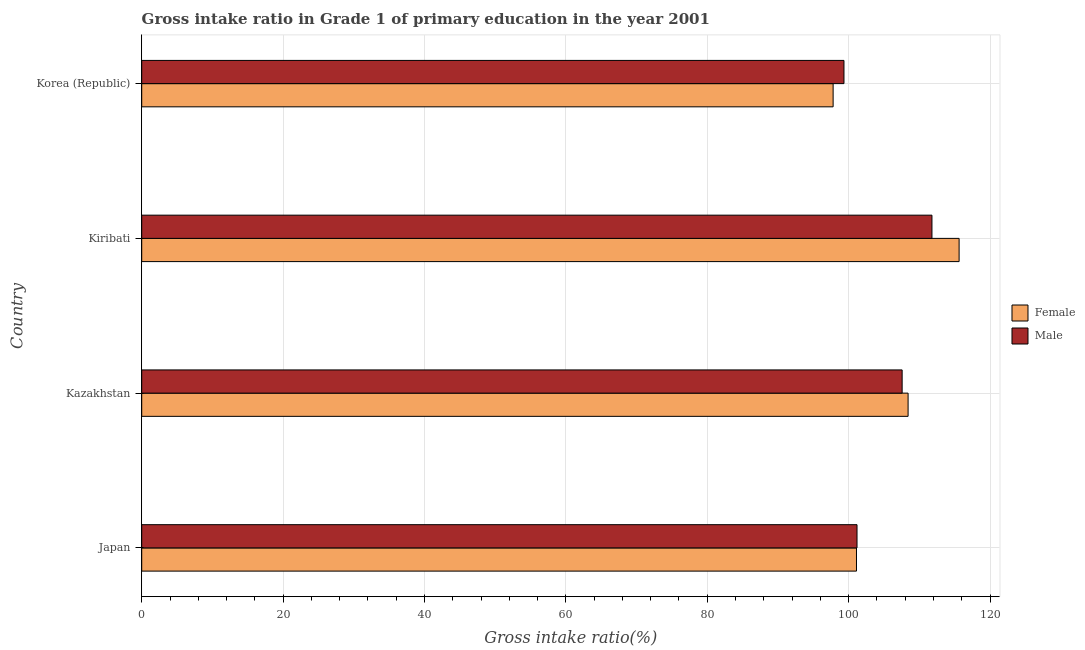How many different coloured bars are there?
Keep it short and to the point. 2. Are the number of bars per tick equal to the number of legend labels?
Make the answer very short. Yes. Are the number of bars on each tick of the Y-axis equal?
Offer a very short reply. Yes. How many bars are there on the 2nd tick from the top?
Provide a short and direct response. 2. In how many cases, is the number of bars for a given country not equal to the number of legend labels?
Provide a short and direct response. 0. What is the gross intake ratio(male) in Kiribati?
Your answer should be compact. 111.78. Across all countries, what is the maximum gross intake ratio(male)?
Provide a short and direct response. 111.78. Across all countries, what is the minimum gross intake ratio(female)?
Ensure brevity in your answer.  97.8. In which country was the gross intake ratio(male) maximum?
Ensure brevity in your answer.  Kiribati. In which country was the gross intake ratio(female) minimum?
Give a very brief answer. Korea (Republic). What is the total gross intake ratio(male) in the graph?
Ensure brevity in your answer.  419.87. What is the difference between the gross intake ratio(male) in Japan and that in Kazakhstan?
Make the answer very short. -6.38. What is the difference between the gross intake ratio(male) in Japan and the gross intake ratio(female) in Kazakhstan?
Your response must be concise. -7.23. What is the average gross intake ratio(male) per country?
Keep it short and to the point. 104.97. What is the difference between the gross intake ratio(female) and gross intake ratio(male) in Japan?
Make the answer very short. -0.08. What is the ratio of the gross intake ratio(female) in Kazakhstan to that in Korea (Republic)?
Give a very brief answer. 1.11. Is the gross intake ratio(male) in Japan less than that in Kiribati?
Make the answer very short. Yes. What is the difference between the highest and the second highest gross intake ratio(female)?
Provide a succinct answer. 7.21. What is the difference between the highest and the lowest gross intake ratio(female)?
Ensure brevity in your answer.  17.82. Is the sum of the gross intake ratio(male) in Kazakhstan and Kiribati greater than the maximum gross intake ratio(female) across all countries?
Keep it short and to the point. Yes. What does the 1st bar from the bottom in Kazakhstan represents?
Offer a very short reply. Female. Are all the bars in the graph horizontal?
Provide a succinct answer. Yes. How many countries are there in the graph?
Keep it short and to the point. 4. Does the graph contain any zero values?
Your answer should be compact. No. Does the graph contain grids?
Make the answer very short. Yes. Where does the legend appear in the graph?
Offer a terse response. Center right. How are the legend labels stacked?
Provide a short and direct response. Vertical. What is the title of the graph?
Provide a short and direct response. Gross intake ratio in Grade 1 of primary education in the year 2001. Does "Merchandise exports" appear as one of the legend labels in the graph?
Your answer should be very brief. No. What is the label or title of the X-axis?
Provide a short and direct response. Gross intake ratio(%). What is the Gross intake ratio(%) of Female in Japan?
Ensure brevity in your answer.  101.11. What is the Gross intake ratio(%) of Male in Japan?
Offer a very short reply. 101.18. What is the Gross intake ratio(%) of Female in Kazakhstan?
Give a very brief answer. 108.41. What is the Gross intake ratio(%) of Male in Kazakhstan?
Make the answer very short. 107.57. What is the Gross intake ratio(%) in Female in Kiribati?
Offer a terse response. 115.62. What is the Gross intake ratio(%) in Male in Kiribati?
Ensure brevity in your answer.  111.78. What is the Gross intake ratio(%) of Female in Korea (Republic)?
Your answer should be very brief. 97.8. What is the Gross intake ratio(%) of Male in Korea (Republic)?
Keep it short and to the point. 99.34. Across all countries, what is the maximum Gross intake ratio(%) of Female?
Make the answer very short. 115.62. Across all countries, what is the maximum Gross intake ratio(%) of Male?
Provide a short and direct response. 111.78. Across all countries, what is the minimum Gross intake ratio(%) in Female?
Your answer should be very brief. 97.8. Across all countries, what is the minimum Gross intake ratio(%) in Male?
Provide a short and direct response. 99.34. What is the total Gross intake ratio(%) of Female in the graph?
Keep it short and to the point. 422.95. What is the total Gross intake ratio(%) in Male in the graph?
Give a very brief answer. 419.87. What is the difference between the Gross intake ratio(%) of Female in Japan and that in Kazakhstan?
Provide a short and direct response. -7.3. What is the difference between the Gross intake ratio(%) in Male in Japan and that in Kazakhstan?
Your response must be concise. -6.38. What is the difference between the Gross intake ratio(%) of Female in Japan and that in Kiribati?
Give a very brief answer. -14.52. What is the difference between the Gross intake ratio(%) of Male in Japan and that in Kiribati?
Your response must be concise. -10.6. What is the difference between the Gross intake ratio(%) in Female in Japan and that in Korea (Republic)?
Give a very brief answer. 3.3. What is the difference between the Gross intake ratio(%) of Male in Japan and that in Korea (Republic)?
Ensure brevity in your answer.  1.85. What is the difference between the Gross intake ratio(%) in Female in Kazakhstan and that in Kiribati?
Your answer should be compact. -7.22. What is the difference between the Gross intake ratio(%) in Male in Kazakhstan and that in Kiribati?
Provide a succinct answer. -4.22. What is the difference between the Gross intake ratio(%) in Female in Kazakhstan and that in Korea (Republic)?
Make the answer very short. 10.61. What is the difference between the Gross intake ratio(%) of Male in Kazakhstan and that in Korea (Republic)?
Provide a short and direct response. 8.23. What is the difference between the Gross intake ratio(%) of Female in Kiribati and that in Korea (Republic)?
Offer a terse response. 17.82. What is the difference between the Gross intake ratio(%) in Male in Kiribati and that in Korea (Republic)?
Your response must be concise. 12.45. What is the difference between the Gross intake ratio(%) in Female in Japan and the Gross intake ratio(%) in Male in Kazakhstan?
Provide a short and direct response. -6.46. What is the difference between the Gross intake ratio(%) in Female in Japan and the Gross intake ratio(%) in Male in Kiribati?
Offer a terse response. -10.68. What is the difference between the Gross intake ratio(%) of Female in Japan and the Gross intake ratio(%) of Male in Korea (Republic)?
Ensure brevity in your answer.  1.77. What is the difference between the Gross intake ratio(%) in Female in Kazakhstan and the Gross intake ratio(%) in Male in Kiribati?
Ensure brevity in your answer.  -3.37. What is the difference between the Gross intake ratio(%) in Female in Kazakhstan and the Gross intake ratio(%) in Male in Korea (Republic)?
Your answer should be very brief. 9.07. What is the difference between the Gross intake ratio(%) of Female in Kiribati and the Gross intake ratio(%) of Male in Korea (Republic)?
Provide a succinct answer. 16.29. What is the average Gross intake ratio(%) of Female per country?
Give a very brief answer. 105.74. What is the average Gross intake ratio(%) in Male per country?
Your response must be concise. 104.97. What is the difference between the Gross intake ratio(%) in Female and Gross intake ratio(%) in Male in Japan?
Provide a succinct answer. -0.08. What is the difference between the Gross intake ratio(%) in Female and Gross intake ratio(%) in Male in Kazakhstan?
Give a very brief answer. 0.84. What is the difference between the Gross intake ratio(%) of Female and Gross intake ratio(%) of Male in Kiribati?
Provide a short and direct response. 3.84. What is the difference between the Gross intake ratio(%) in Female and Gross intake ratio(%) in Male in Korea (Republic)?
Keep it short and to the point. -1.53. What is the ratio of the Gross intake ratio(%) in Female in Japan to that in Kazakhstan?
Give a very brief answer. 0.93. What is the ratio of the Gross intake ratio(%) of Male in Japan to that in Kazakhstan?
Provide a short and direct response. 0.94. What is the ratio of the Gross intake ratio(%) of Female in Japan to that in Kiribati?
Your answer should be compact. 0.87. What is the ratio of the Gross intake ratio(%) of Male in Japan to that in Kiribati?
Make the answer very short. 0.91. What is the ratio of the Gross intake ratio(%) in Female in Japan to that in Korea (Republic)?
Your response must be concise. 1.03. What is the ratio of the Gross intake ratio(%) in Male in Japan to that in Korea (Republic)?
Your answer should be very brief. 1.02. What is the ratio of the Gross intake ratio(%) in Female in Kazakhstan to that in Kiribati?
Ensure brevity in your answer.  0.94. What is the ratio of the Gross intake ratio(%) in Male in Kazakhstan to that in Kiribati?
Give a very brief answer. 0.96. What is the ratio of the Gross intake ratio(%) in Female in Kazakhstan to that in Korea (Republic)?
Your response must be concise. 1.11. What is the ratio of the Gross intake ratio(%) in Male in Kazakhstan to that in Korea (Republic)?
Give a very brief answer. 1.08. What is the ratio of the Gross intake ratio(%) of Female in Kiribati to that in Korea (Republic)?
Make the answer very short. 1.18. What is the ratio of the Gross intake ratio(%) of Male in Kiribati to that in Korea (Republic)?
Make the answer very short. 1.13. What is the difference between the highest and the second highest Gross intake ratio(%) in Female?
Your answer should be very brief. 7.22. What is the difference between the highest and the second highest Gross intake ratio(%) in Male?
Offer a terse response. 4.22. What is the difference between the highest and the lowest Gross intake ratio(%) of Female?
Provide a short and direct response. 17.82. What is the difference between the highest and the lowest Gross intake ratio(%) in Male?
Provide a succinct answer. 12.45. 